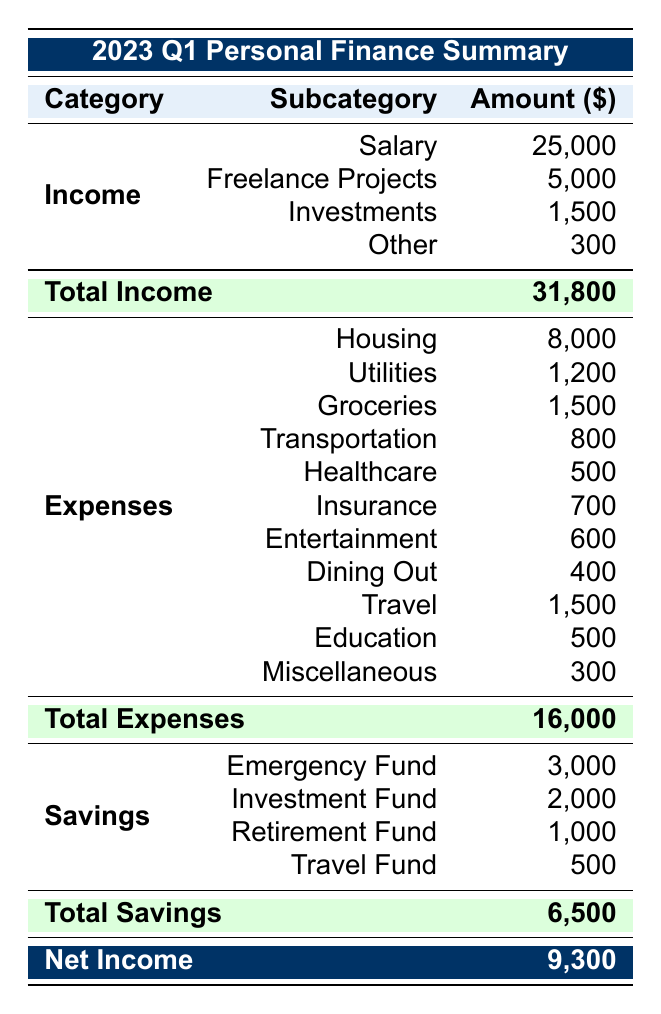What is the total income for 2023 Q1? The total income can be found in the table under the "Total Income" section. The total amount listed there is 31,800.
Answer: 31,800 How much did you spend on groceries in 2023 Q1? The amount spent on groceries is specifically listed in the "Expenses" section. It shows an expense of 1,500 for groceries.
Answer: 1,500 Is the total savings more than the total expenses? The total savings is 6,500 and the total expenses is 16,000. Since 6,500 is less than 16,000, the answer is no.
Answer: No What is the difference between total income and total expenses? The total income is 31,800 and the total expenses are 16,000. The difference is calculated by subtracting total expenses from total income: 31,800 - 16,000 = 15,800.
Answer: 15,800 How much is allocated to the Emergency Fund? The amount allocated to the Emergency Fund is stated directly in the "Savings" section as 3,000.
Answer: 3,000 Which category had the highest expense in 2023 Q1? By examining the "Expenses" section, we see that Housing has the highest expenditure of 8,000 compared to other expense items.
Answer: Housing Calculate the average spending on Transportation and Dining Out combined. The amounts for Transportation and Dining Out are 800 and 400, respectively. To find the average, add those amounts together (800 + 400 = 1,200) and then divide by the count of categories (2): 1,200 / 2 = 600.
Answer: 600 Did the individual allocate any amount towards a Travel Fund? Checking the "Savings" section, the Travel Fund is listed with an amount of 500, which indicates that there is an allocation. Thus, the answer is yes.
Answer: Yes What percentage of total income was spent on healthcare? The amount spent on healthcare is 500 and the total income is 31,800. To find the percentage, divide 500 by 31,800 and multiply by 100: (500 / 31,800) * 100 ≈ 1.57%.
Answer: Approximately 1.57% 